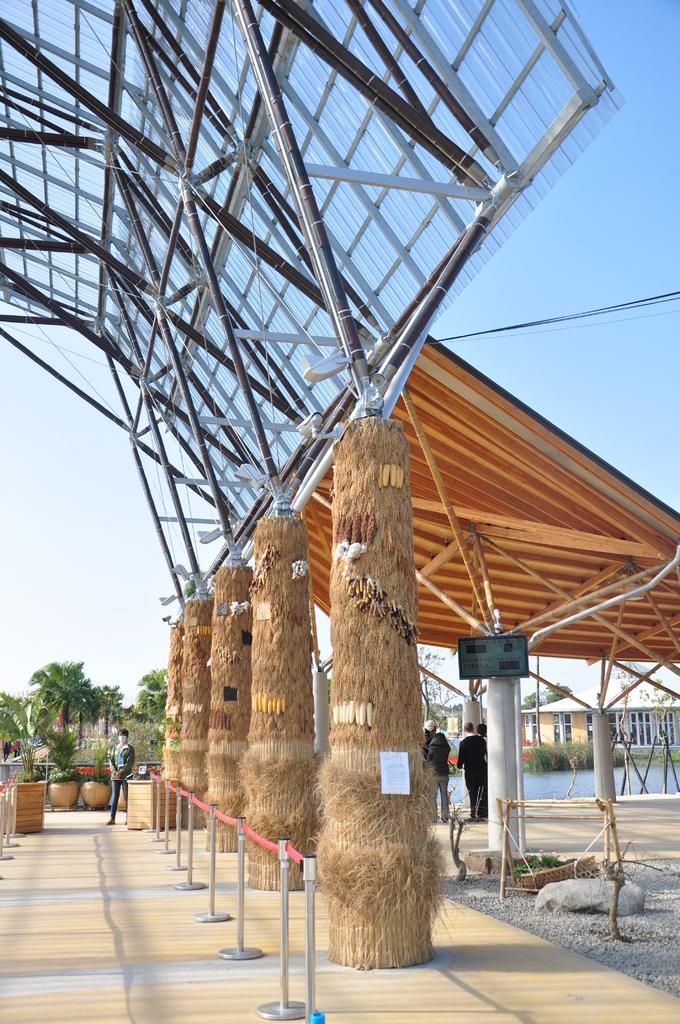What are the people in the image doing? The people in the image are standing on the ground. What can be seen in the background of the image? In the background of the image, there are trees, water, a building, the sky, plant pots, and other objects. Can you describe the natural elements visible in the image? The natural elements visible in the image include trees and water. What type of structure is visible in the background of the image? There is a building visible in the background of the image. What type of lipstick is the person wearing in the image? There is no person wearing lipstick in the image. What season is depicted in the image? The provided facts do not mention any season, so it cannot be determined from the image. 